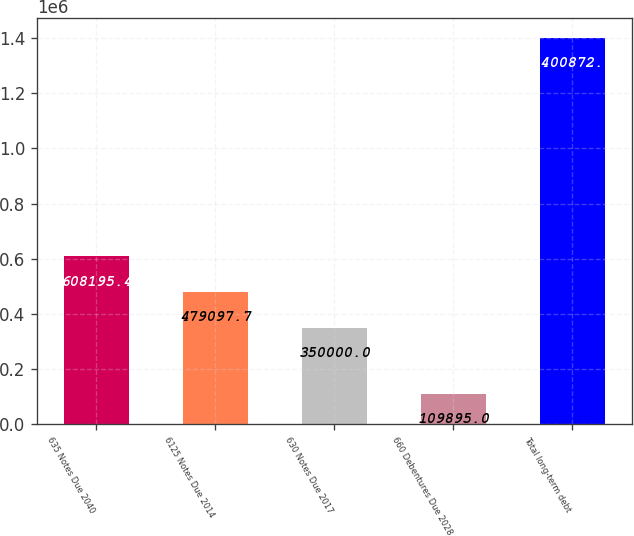Convert chart. <chart><loc_0><loc_0><loc_500><loc_500><bar_chart><fcel>635 Notes Due 2040<fcel>6125 Notes Due 2014<fcel>630 Notes Due 2017<fcel>660 Debentures Due 2028<fcel>Total long-term debt<nl><fcel>608195<fcel>479098<fcel>350000<fcel>109895<fcel>1.40087e+06<nl></chart> 